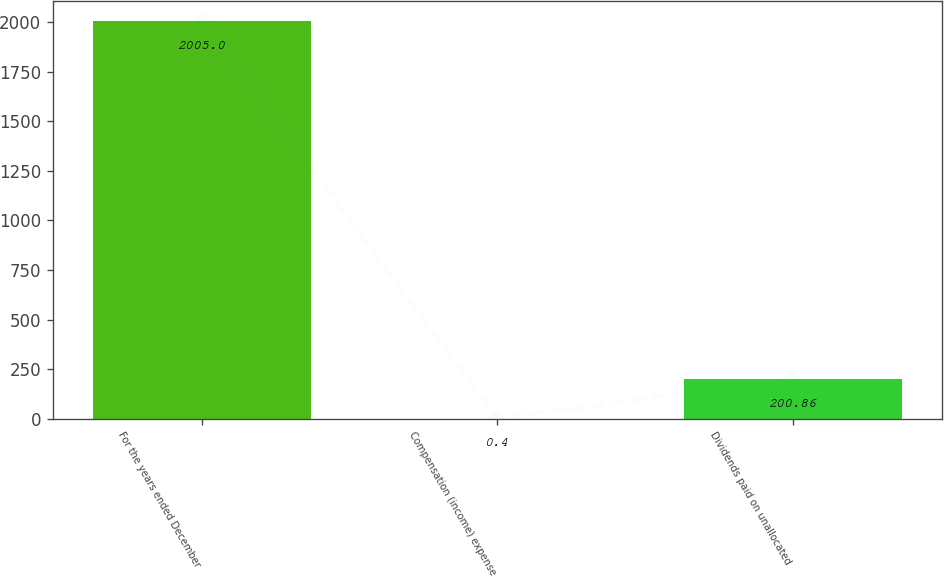Convert chart to OTSL. <chart><loc_0><loc_0><loc_500><loc_500><bar_chart><fcel>For the years ended December<fcel>Compensation (income) expense<fcel>Dividends paid on unallocated<nl><fcel>2005<fcel>0.4<fcel>200.86<nl></chart> 